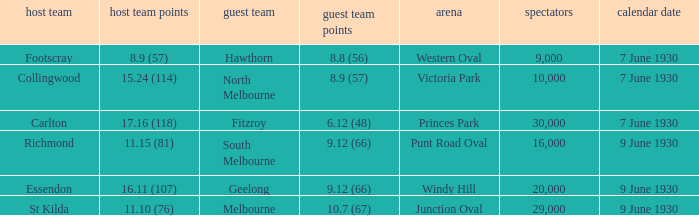What is the smallest crowd to see the away team score 10.7 (67)? 29000.0. 